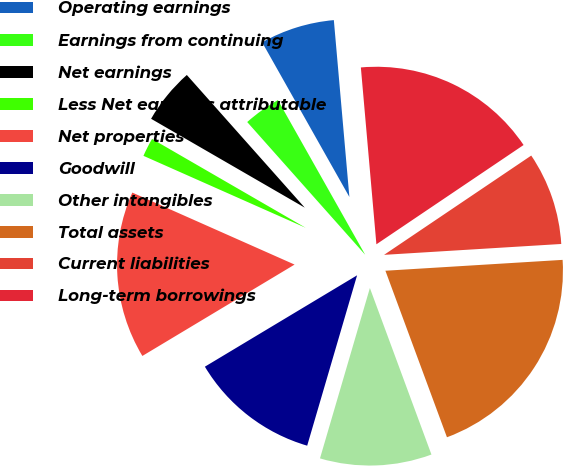Convert chart. <chart><loc_0><loc_0><loc_500><loc_500><pie_chart><fcel>Operating earnings<fcel>Earnings from continuing<fcel>Net earnings<fcel>Less Net earnings attributable<fcel>Net properties<fcel>Goodwill<fcel>Other intangibles<fcel>Total assets<fcel>Current liabilities<fcel>Long-term borrowings<nl><fcel>6.78%<fcel>3.39%<fcel>5.09%<fcel>1.7%<fcel>15.25%<fcel>11.86%<fcel>10.17%<fcel>20.34%<fcel>8.47%<fcel>16.95%<nl></chart> 